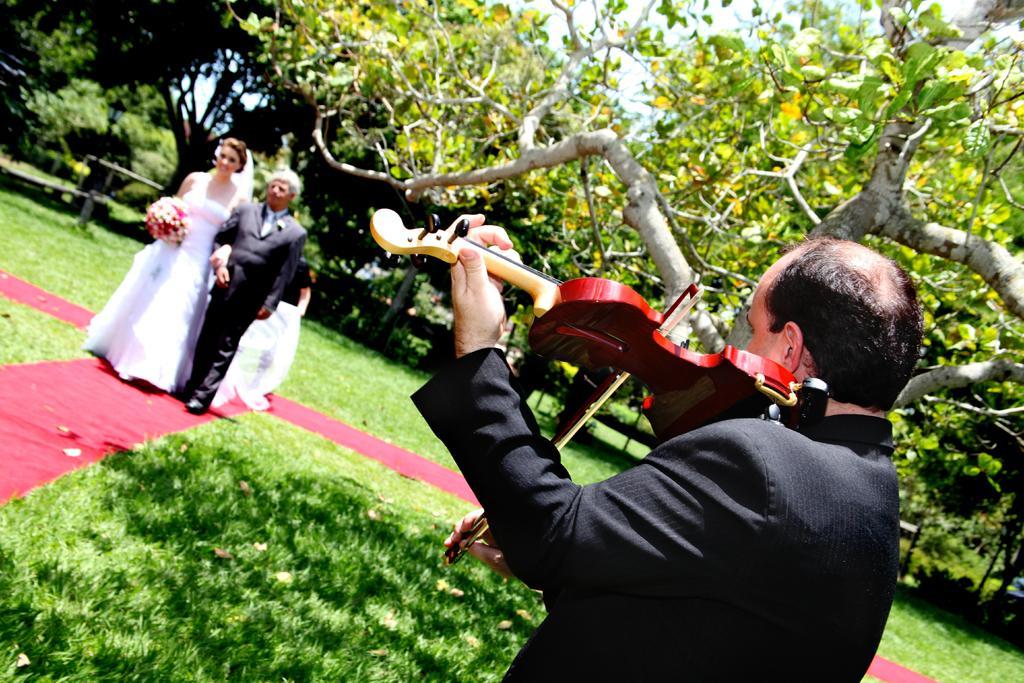Describe this image in one or two sentences. In this image I can see the grass. On the right side, I can see a person holding a musical instrument. On the left side I can see a couple. In the background, I can see the trees. 